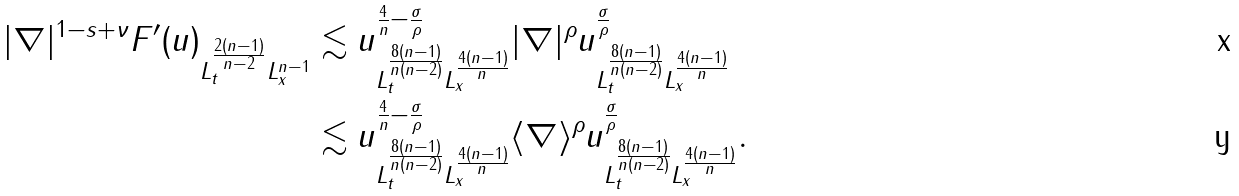<formula> <loc_0><loc_0><loc_500><loc_500>\| | \nabla | ^ { 1 - s + \nu } F ^ { \prime } ( u ) \| _ { L ^ { \frac { 2 ( n - 1 ) } { n - 2 } } _ { t } L ^ { n - 1 } _ { x } } & \lesssim \| u \| ^ { \frac { 4 } { n } - \frac { \sigma } { \rho } } _ { L ^ { \frac { 8 ( n - 1 ) } { n ( n - 2 ) } } _ { t } L ^ { \frac { 4 ( n - 1 ) } { n } } _ { x } } \| | \nabla | ^ { \rho } u \| ^ { \frac { \sigma } { \rho } } _ { L ^ { \frac { 8 ( n - 1 ) } { n ( n - 2 ) } } _ { t } L ^ { \frac { 4 ( n - 1 ) } { n } } _ { x } } \\ & \lesssim \| u \| ^ { \frac { 4 } { n } - \frac { \sigma } { \rho } } _ { L ^ { \frac { 8 ( n - 1 ) } { n ( n - 2 ) } } _ { t } L ^ { \frac { 4 ( n - 1 ) } { n } } _ { x } } \| \langle \nabla \rangle ^ { \rho } u \| ^ { \frac { \sigma } { \rho } } _ { L ^ { \frac { 8 ( n - 1 ) } { n ( n - 2 ) } } _ { t } L ^ { \frac { 4 ( n - 1 ) } { n } } _ { x } } .</formula> 